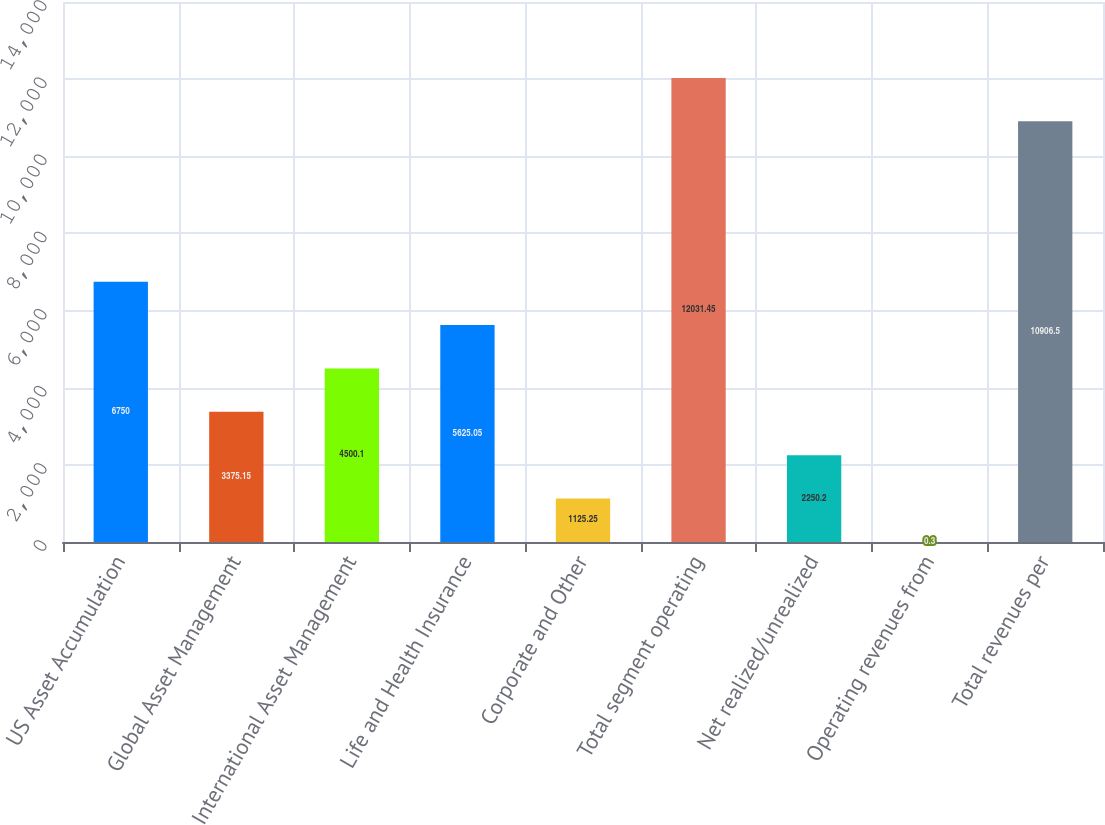Convert chart to OTSL. <chart><loc_0><loc_0><loc_500><loc_500><bar_chart><fcel>US Asset Accumulation<fcel>Global Asset Management<fcel>International Asset Management<fcel>Life and Health Insurance<fcel>Corporate and Other<fcel>Total segment operating<fcel>Net realized/unrealized<fcel>Operating revenues from<fcel>Total revenues per<nl><fcel>6750<fcel>3375.15<fcel>4500.1<fcel>5625.05<fcel>1125.25<fcel>12031.5<fcel>2250.2<fcel>0.3<fcel>10906.5<nl></chart> 